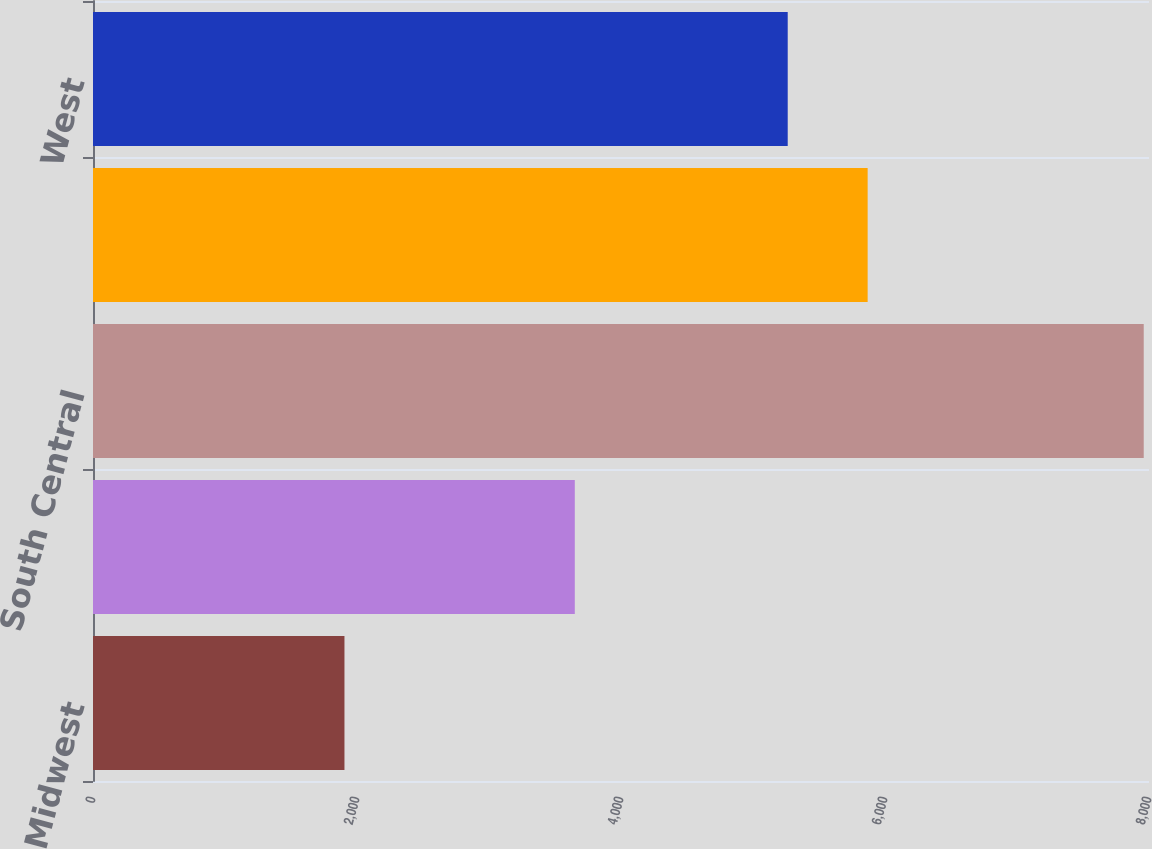Convert chart to OTSL. <chart><loc_0><loc_0><loc_500><loc_500><bar_chart><fcel>Midwest<fcel>Southeast<fcel>South Central<fcel>Southwest<fcel>West<nl><fcel>1905<fcel>3650<fcel>7960<fcel>5868.5<fcel>5263<nl></chart> 